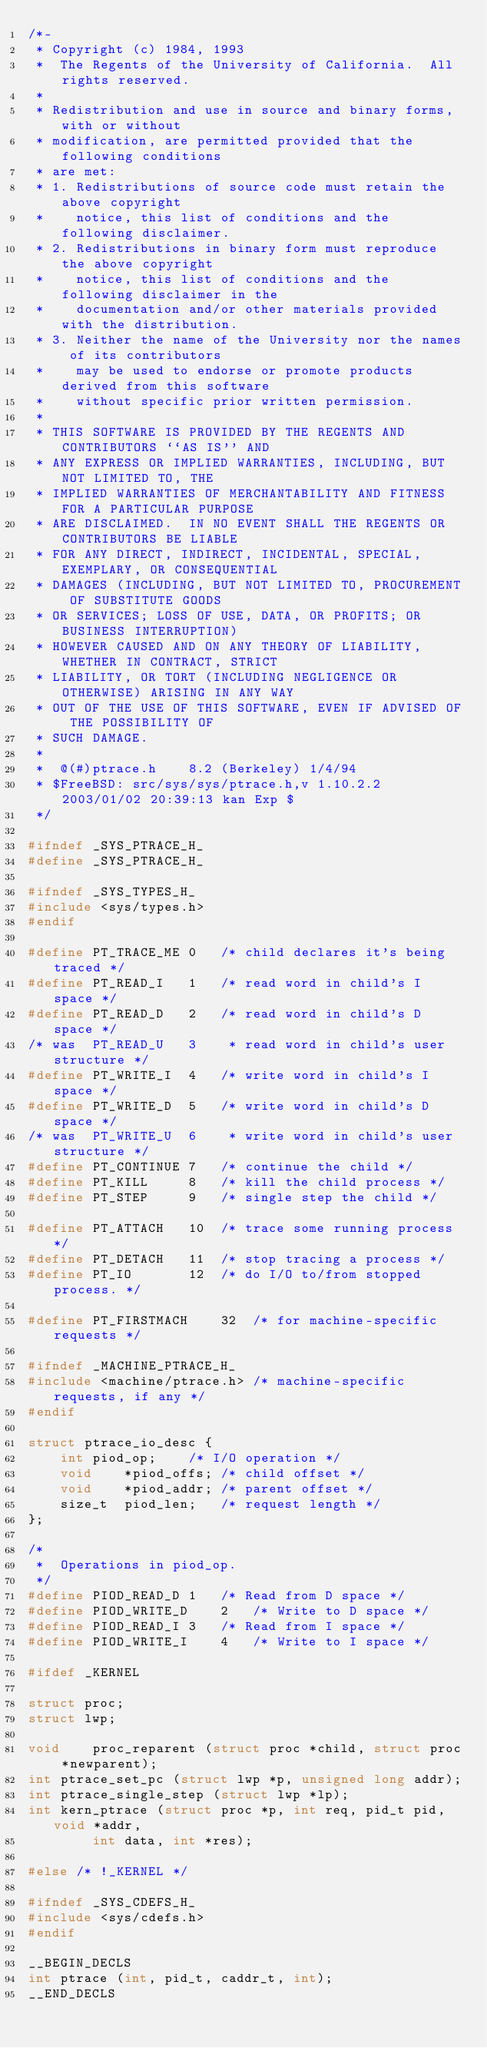Convert code to text. <code><loc_0><loc_0><loc_500><loc_500><_C_>/*-
 * Copyright (c) 1984, 1993
 *	The Regents of the University of California.  All rights reserved.
 *
 * Redistribution and use in source and binary forms, with or without
 * modification, are permitted provided that the following conditions
 * are met:
 * 1. Redistributions of source code must retain the above copyright
 *    notice, this list of conditions and the following disclaimer.
 * 2. Redistributions in binary form must reproduce the above copyright
 *    notice, this list of conditions and the following disclaimer in the
 *    documentation and/or other materials provided with the distribution.
 * 3. Neither the name of the University nor the names of its contributors
 *    may be used to endorse or promote products derived from this software
 *    without specific prior written permission.
 *
 * THIS SOFTWARE IS PROVIDED BY THE REGENTS AND CONTRIBUTORS ``AS IS'' AND
 * ANY EXPRESS OR IMPLIED WARRANTIES, INCLUDING, BUT NOT LIMITED TO, THE
 * IMPLIED WARRANTIES OF MERCHANTABILITY AND FITNESS FOR A PARTICULAR PURPOSE
 * ARE DISCLAIMED.  IN NO EVENT SHALL THE REGENTS OR CONTRIBUTORS BE LIABLE
 * FOR ANY DIRECT, INDIRECT, INCIDENTAL, SPECIAL, EXEMPLARY, OR CONSEQUENTIAL
 * DAMAGES (INCLUDING, BUT NOT LIMITED TO, PROCUREMENT OF SUBSTITUTE GOODS
 * OR SERVICES; LOSS OF USE, DATA, OR PROFITS; OR BUSINESS INTERRUPTION)
 * HOWEVER CAUSED AND ON ANY THEORY OF LIABILITY, WHETHER IN CONTRACT, STRICT
 * LIABILITY, OR TORT (INCLUDING NEGLIGENCE OR OTHERWISE) ARISING IN ANY WAY
 * OUT OF THE USE OF THIS SOFTWARE, EVEN IF ADVISED OF THE POSSIBILITY OF
 * SUCH DAMAGE.
 *
 *	@(#)ptrace.h	8.2 (Berkeley) 1/4/94
 * $FreeBSD: src/sys/sys/ptrace.h,v 1.10.2.2 2003/01/02 20:39:13 kan Exp $
 */

#ifndef	_SYS_PTRACE_H_
#define	_SYS_PTRACE_H_

#ifndef _SYS_TYPES_H_
#include <sys/types.h>
#endif

#define	PT_TRACE_ME	0	/* child declares it's being traced */
#define	PT_READ_I	1	/* read word in child's I space */
#define	PT_READ_D	2	/* read word in child's D space */
/* was	PT_READ_U	3	 * read word in child's user structure */
#define	PT_WRITE_I	4	/* write word in child's I space */
#define	PT_WRITE_D	5	/* write word in child's D space */
/* was	PT_WRITE_U	6	 * write word in child's user structure */
#define	PT_CONTINUE	7	/* continue the child */
#define	PT_KILL		8	/* kill the child process */
#define	PT_STEP		9	/* single step the child */

#define	PT_ATTACH	10	/* trace some running process */
#define	PT_DETACH	11	/* stop tracing a process */
#define	PT_IO		12	/* do I/O to/from stopped process. */

#define	PT_FIRSTMACH	32	/* for machine-specific requests */

#ifndef _MACHINE_PTRACE_H_
#include <machine/ptrace.h>	/* machine-specific requests, if any */
#endif

struct ptrace_io_desc {
	int	piod_op;	/* I/O operation */
	void	*piod_offs;	/* child offset */
	void	*piod_addr;	/* parent offset */
	size_t	piod_len;	/* request length */
};

/*
 *  Operations in piod_op.
 */
#define	PIOD_READ_D	1	/* Read from D space */
#define	PIOD_WRITE_D	2	/* Write to D space */
#define	PIOD_READ_I	3	/* Read from I space */
#define	PIOD_WRITE_I	4	/* Write to I space */

#ifdef _KERNEL

struct proc;
struct lwp;

void	proc_reparent (struct proc *child, struct proc *newparent);
int	ptrace_set_pc (struct lwp *p, unsigned long addr);
int	ptrace_single_step (struct lwp *lp);
int	kern_ptrace (struct proc *p, int req, pid_t pid, void *addr,
		int data, int *res);

#else /* !_KERNEL */

#ifndef _SYS_CDEFS_H_
#include <sys/cdefs.h>
#endif

__BEGIN_DECLS
int	ptrace (int, pid_t, caddr_t, int);
__END_DECLS
</code> 